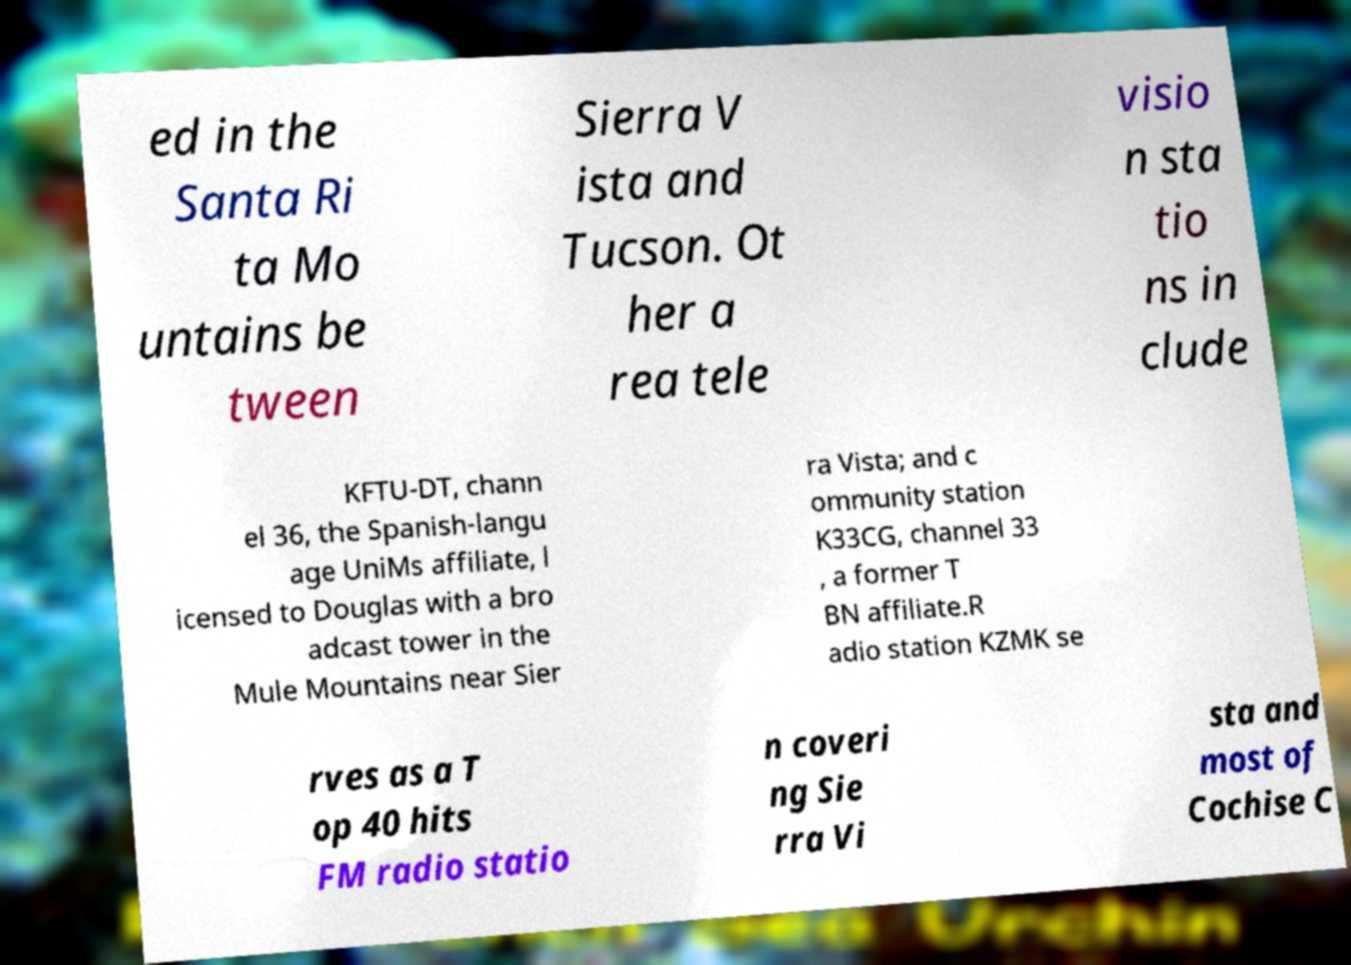Could you extract and type out the text from this image? ed in the Santa Ri ta Mo untains be tween Sierra V ista and Tucson. Ot her a rea tele visio n sta tio ns in clude KFTU-DT, chann el 36, the Spanish-langu age UniMs affiliate, l icensed to Douglas with a bro adcast tower in the Mule Mountains near Sier ra Vista; and c ommunity station K33CG, channel 33 , a former T BN affiliate.R adio station KZMK se rves as a T op 40 hits FM radio statio n coveri ng Sie rra Vi sta and most of Cochise C 